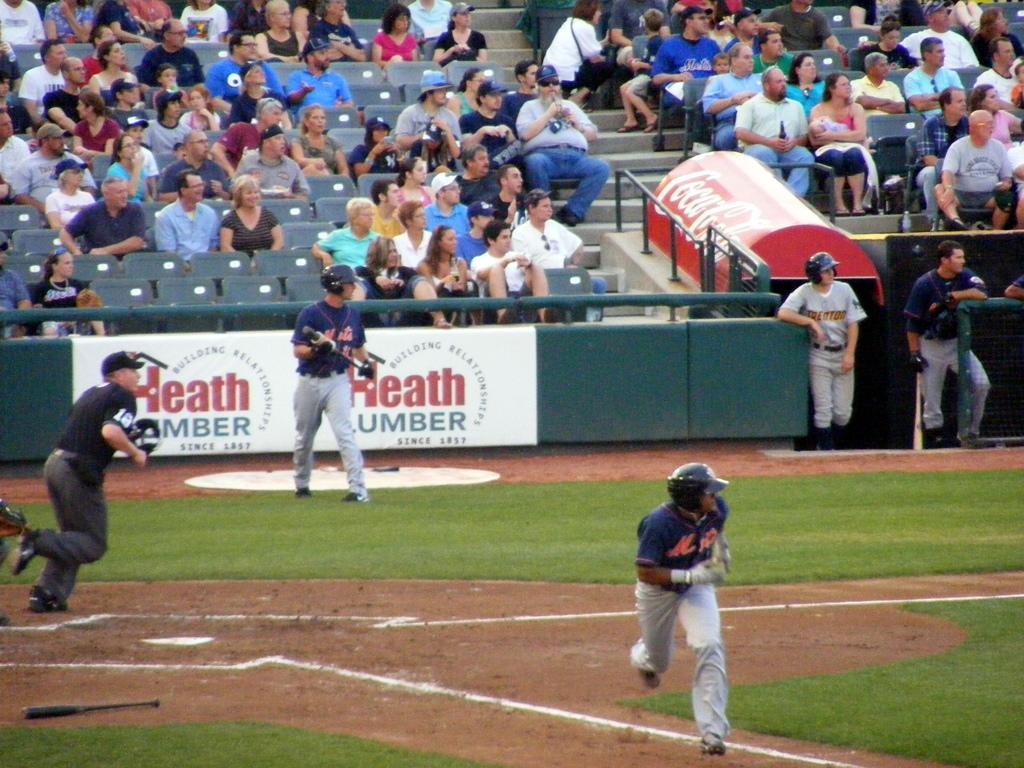<image>
Present a compact description of the photo's key features. Mets baseball player getting ready to run the base. 